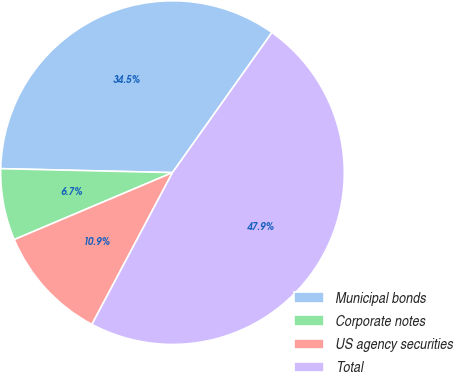Convert chart. <chart><loc_0><loc_0><loc_500><loc_500><pie_chart><fcel>Municipal bonds<fcel>Corporate notes<fcel>US agency securities<fcel>Total<nl><fcel>34.46%<fcel>6.74%<fcel>10.86%<fcel>47.94%<nl></chart> 